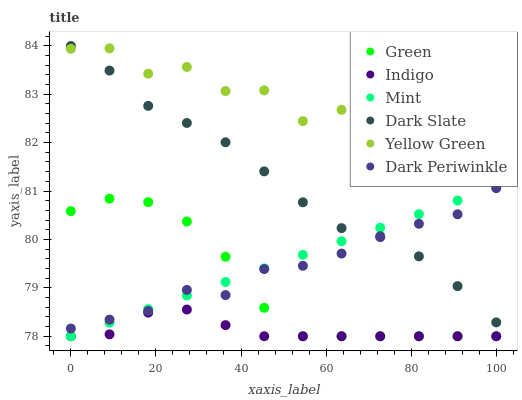Does Indigo have the minimum area under the curve?
Answer yes or no. Yes. Does Yellow Green have the maximum area under the curve?
Answer yes or no. Yes. Does Dark Slate have the minimum area under the curve?
Answer yes or no. No. Does Dark Slate have the maximum area under the curve?
Answer yes or no. No. Is Mint the smoothest?
Answer yes or no. Yes. Is Yellow Green the roughest?
Answer yes or no. Yes. Is Dark Slate the smoothest?
Answer yes or no. No. Is Dark Slate the roughest?
Answer yes or no. No. Does Indigo have the lowest value?
Answer yes or no. Yes. Does Dark Slate have the lowest value?
Answer yes or no. No. Does Dark Slate have the highest value?
Answer yes or no. Yes. Does Yellow Green have the highest value?
Answer yes or no. No. Is Mint less than Yellow Green?
Answer yes or no. Yes. Is Yellow Green greater than Green?
Answer yes or no. Yes. Does Yellow Green intersect Dark Slate?
Answer yes or no. Yes. Is Yellow Green less than Dark Slate?
Answer yes or no. No. Is Yellow Green greater than Dark Slate?
Answer yes or no. No. Does Mint intersect Yellow Green?
Answer yes or no. No. 